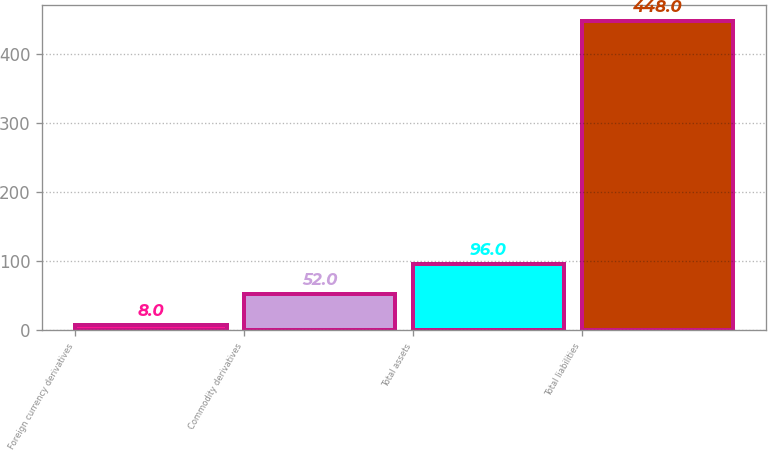Convert chart. <chart><loc_0><loc_0><loc_500><loc_500><bar_chart><fcel>Foreign currency derivatives<fcel>Commodity derivatives<fcel>Total assets<fcel>Total liabilities<nl><fcel>8<fcel>52<fcel>96<fcel>448<nl></chart> 